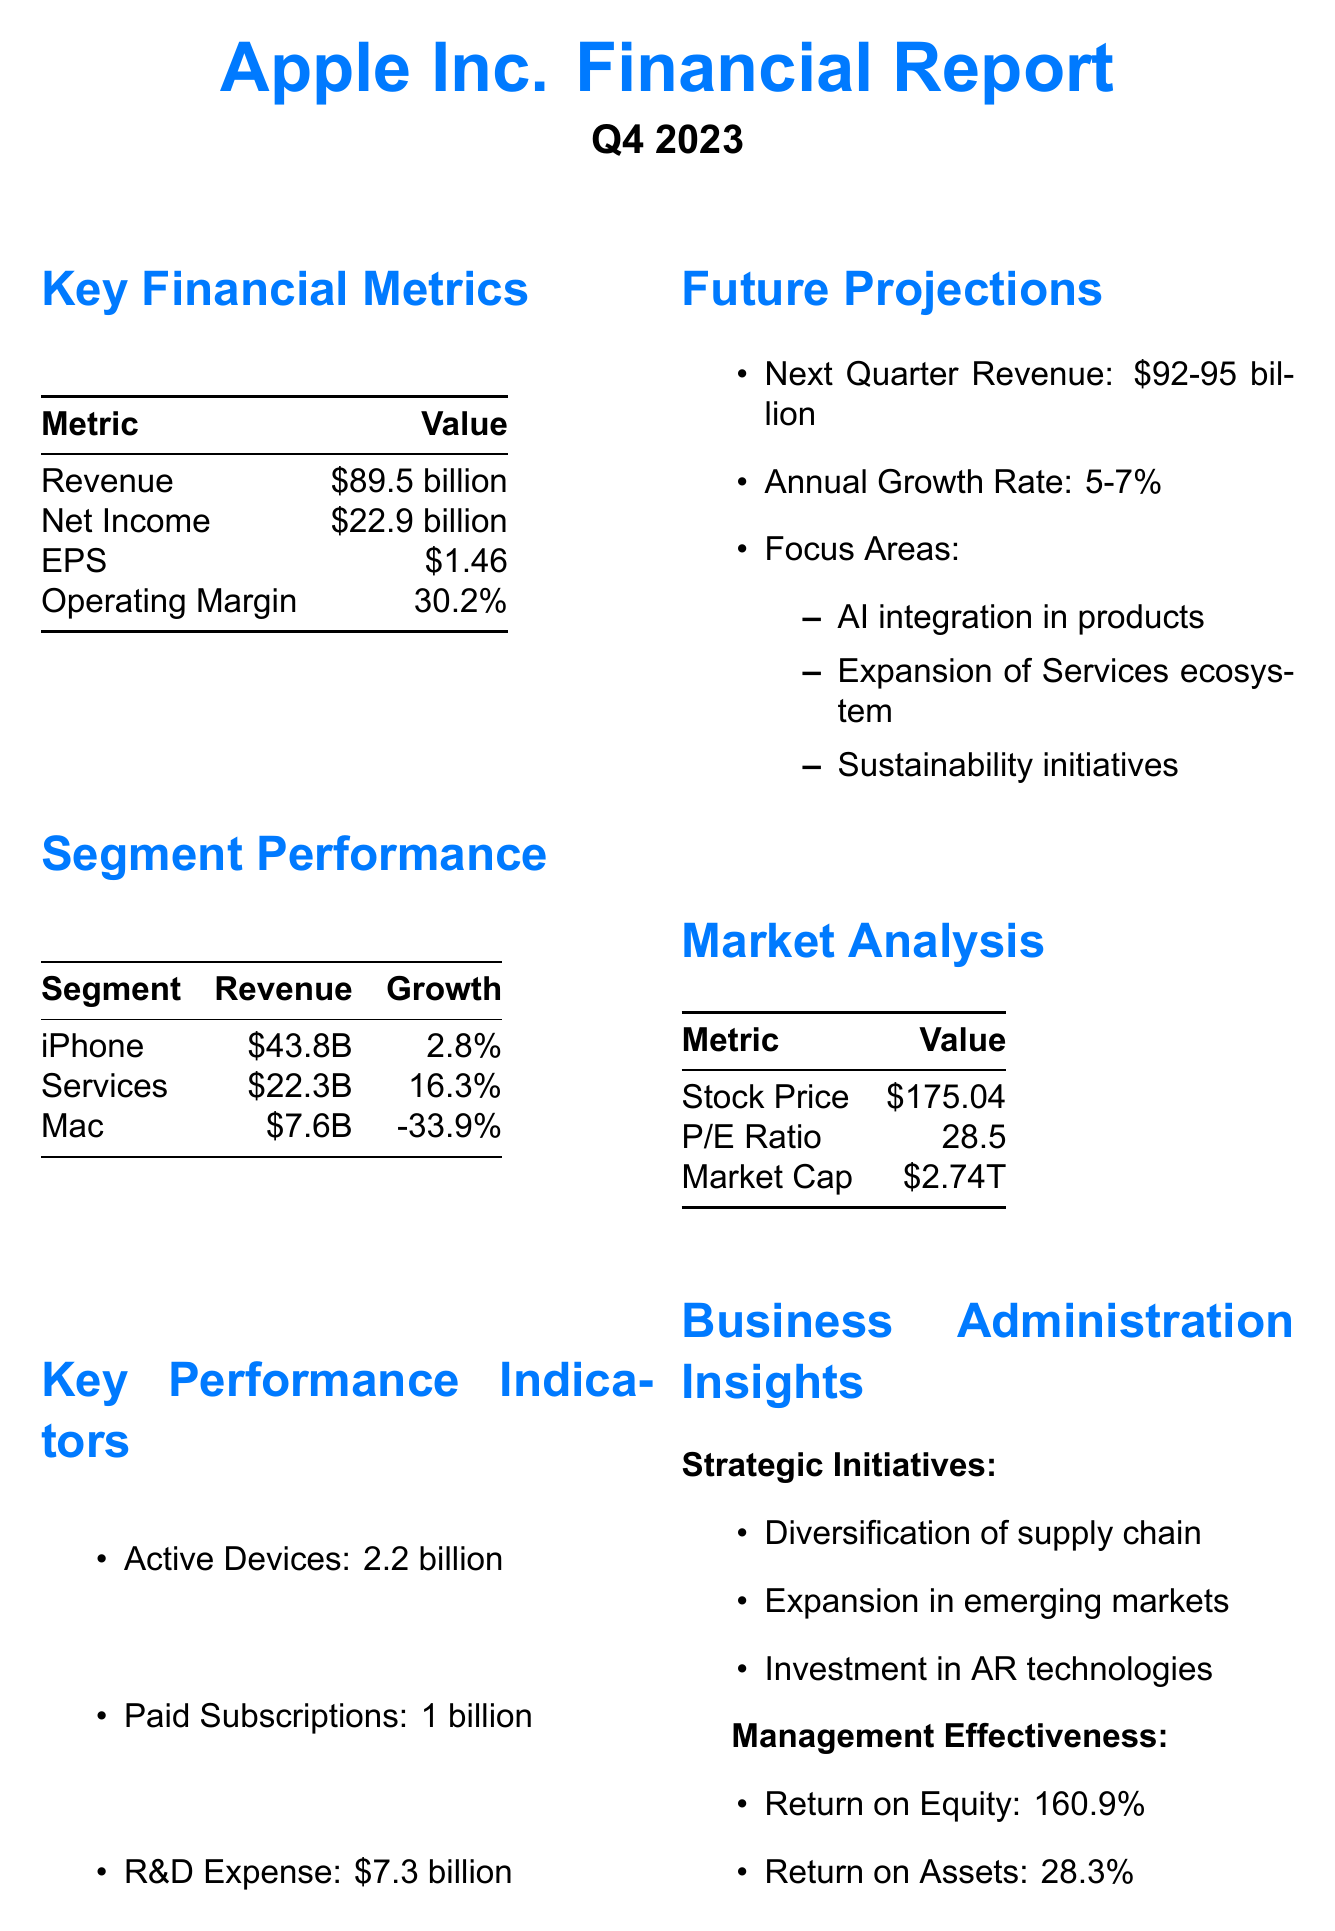What is the revenue for Q4 2023? The revenue for Q4 2023 is stated in the key financial metrics section of the document.
Answer: $89.5 billion What was the growth rate for the Services segment? The growth rate for the Services segment is available in the segment performance section of the document.
Answer: 16.3% What is the net income for Apple Inc.? The net income can be found within the key financial metrics of the report.
Answer: $22.9 billion What are the focus areas for future projections? The focus areas for future projections are listed under the future projections section and encompass several initiatives.
Answer: AI integration in products, Expansion of Services ecosystem, Sustainability initiatives What is the price-to-earnings ratio reported? The price-to-earnings ratio is part of the market analysis section and reflects the company's valuation.
Answer: 28.5 Explain the operating margin percentage. The operating margin percentage is provided in the key financial metrics section and indicates the profitability of the company.
Answer: 30.2% What was the revenue for the iPhone segment? The revenue for the iPhone segment is detailed in the segment performance section of the document.
Answer: $43.8 billion What is the total number of paid subscriptions? The total number of paid subscriptions is mentioned in the key performance indicators.
Answer: 1 billion What is the market capitalization of Apple Inc.? The market capitalization is listed under the market analysis section, indicating the company's total market value.
Answer: $2.74 trillion 